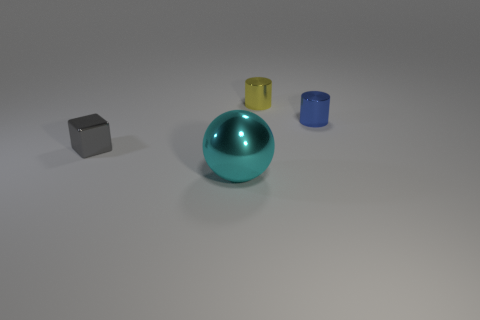Subtract 2 cylinders. How many cylinders are left? 0 Add 1 large brown metal things. How many objects exist? 5 Subtract all red cylinders. How many yellow balls are left? 0 Subtract all gray blocks. Subtract all small gray metallic things. How many objects are left? 2 Add 3 small yellow metallic cylinders. How many small yellow metallic cylinders are left? 4 Add 4 small balls. How many small balls exist? 4 Subtract all blue cylinders. How many cylinders are left? 1 Subtract 0 brown spheres. How many objects are left? 4 Subtract all cubes. How many objects are left? 3 Subtract all red cylinders. Subtract all brown blocks. How many cylinders are left? 2 